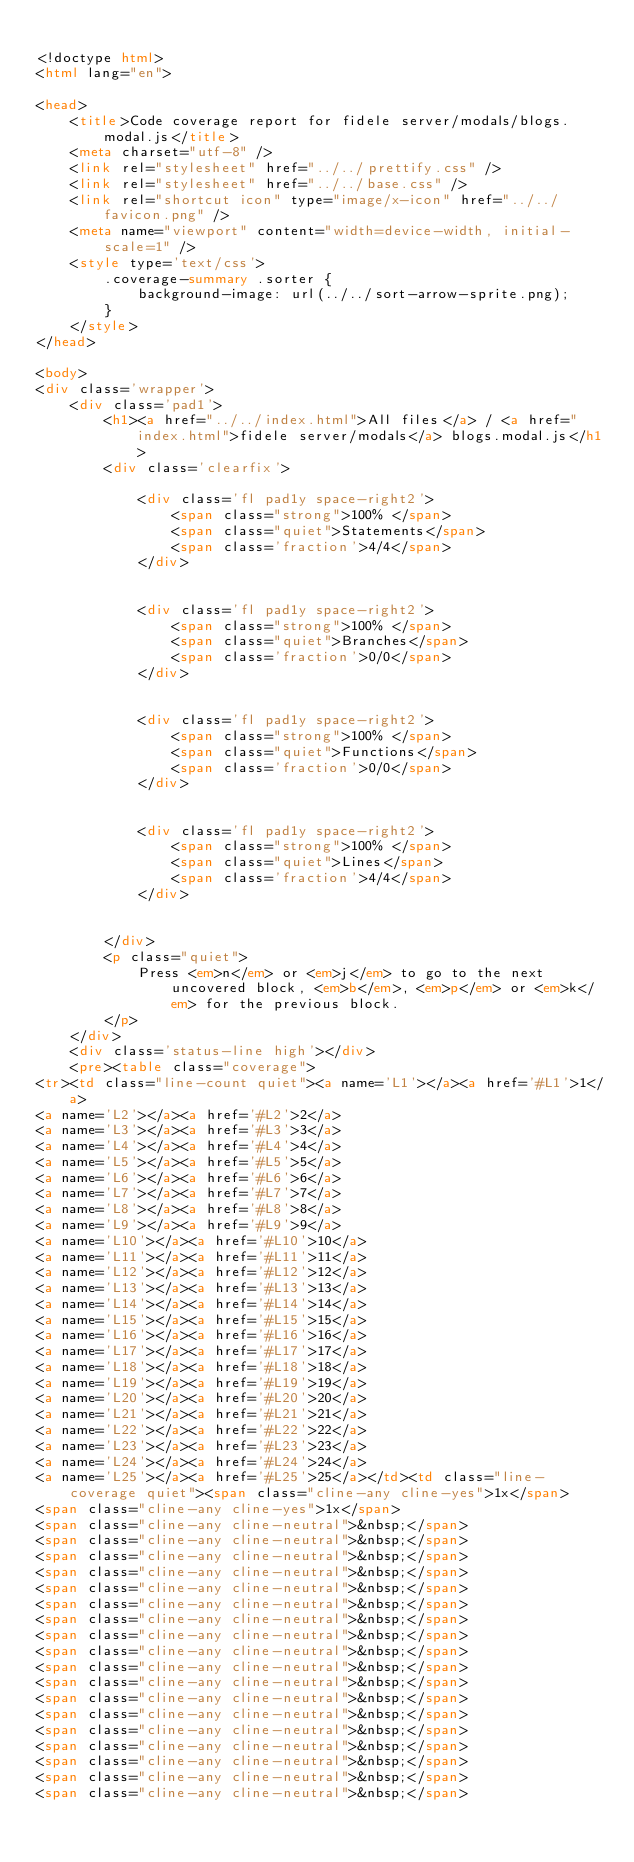<code> <loc_0><loc_0><loc_500><loc_500><_HTML_>
<!doctype html>
<html lang="en">

<head>
    <title>Code coverage report for fidele server/modals/blogs.modal.js</title>
    <meta charset="utf-8" />
    <link rel="stylesheet" href="../../prettify.css" />
    <link rel="stylesheet" href="../../base.css" />
    <link rel="shortcut icon" type="image/x-icon" href="../../favicon.png" />
    <meta name="viewport" content="width=device-width, initial-scale=1" />
    <style type='text/css'>
        .coverage-summary .sorter {
            background-image: url(../../sort-arrow-sprite.png);
        }
    </style>
</head>
    
<body>
<div class='wrapper'>
    <div class='pad1'>
        <h1><a href="../../index.html">All files</a> / <a href="index.html">fidele server/modals</a> blogs.modal.js</h1>
        <div class='clearfix'>
            
            <div class='fl pad1y space-right2'>
                <span class="strong">100% </span>
                <span class="quiet">Statements</span>
                <span class='fraction'>4/4</span>
            </div>
        
            
            <div class='fl pad1y space-right2'>
                <span class="strong">100% </span>
                <span class="quiet">Branches</span>
                <span class='fraction'>0/0</span>
            </div>
        
            
            <div class='fl pad1y space-right2'>
                <span class="strong">100% </span>
                <span class="quiet">Functions</span>
                <span class='fraction'>0/0</span>
            </div>
        
            
            <div class='fl pad1y space-right2'>
                <span class="strong">100% </span>
                <span class="quiet">Lines</span>
                <span class='fraction'>4/4</span>
            </div>
        
            
        </div>
        <p class="quiet">
            Press <em>n</em> or <em>j</em> to go to the next uncovered block, <em>b</em>, <em>p</em> or <em>k</em> for the previous block.
        </p>
    </div>
    <div class='status-line high'></div>
    <pre><table class="coverage">
<tr><td class="line-count quiet"><a name='L1'></a><a href='#L1'>1</a>
<a name='L2'></a><a href='#L2'>2</a>
<a name='L3'></a><a href='#L3'>3</a>
<a name='L4'></a><a href='#L4'>4</a>
<a name='L5'></a><a href='#L5'>5</a>
<a name='L6'></a><a href='#L6'>6</a>
<a name='L7'></a><a href='#L7'>7</a>
<a name='L8'></a><a href='#L8'>8</a>
<a name='L9'></a><a href='#L9'>9</a>
<a name='L10'></a><a href='#L10'>10</a>
<a name='L11'></a><a href='#L11'>11</a>
<a name='L12'></a><a href='#L12'>12</a>
<a name='L13'></a><a href='#L13'>13</a>
<a name='L14'></a><a href='#L14'>14</a>
<a name='L15'></a><a href='#L15'>15</a>
<a name='L16'></a><a href='#L16'>16</a>
<a name='L17'></a><a href='#L17'>17</a>
<a name='L18'></a><a href='#L18'>18</a>
<a name='L19'></a><a href='#L19'>19</a>
<a name='L20'></a><a href='#L20'>20</a>
<a name='L21'></a><a href='#L21'>21</a>
<a name='L22'></a><a href='#L22'>22</a>
<a name='L23'></a><a href='#L23'>23</a>
<a name='L24'></a><a href='#L24'>24</a>
<a name='L25'></a><a href='#L25'>25</a></td><td class="line-coverage quiet"><span class="cline-any cline-yes">1x</span>
<span class="cline-any cline-yes">1x</span>
<span class="cline-any cline-neutral">&nbsp;</span>
<span class="cline-any cline-neutral">&nbsp;</span>
<span class="cline-any cline-neutral">&nbsp;</span>
<span class="cline-any cline-neutral">&nbsp;</span>
<span class="cline-any cline-neutral">&nbsp;</span>
<span class="cline-any cline-neutral">&nbsp;</span>
<span class="cline-any cline-neutral">&nbsp;</span>
<span class="cline-any cline-neutral">&nbsp;</span>
<span class="cline-any cline-neutral">&nbsp;</span>
<span class="cline-any cline-neutral">&nbsp;</span>
<span class="cline-any cline-neutral">&nbsp;</span>
<span class="cline-any cline-neutral">&nbsp;</span>
<span class="cline-any cline-neutral">&nbsp;</span>
<span class="cline-any cline-neutral">&nbsp;</span>
<span class="cline-any cline-neutral">&nbsp;</span>
<span class="cline-any cline-neutral">&nbsp;</span>
<span class="cline-any cline-neutral">&nbsp;</span>
<span class="cline-any cline-neutral">&nbsp;</span></code> 